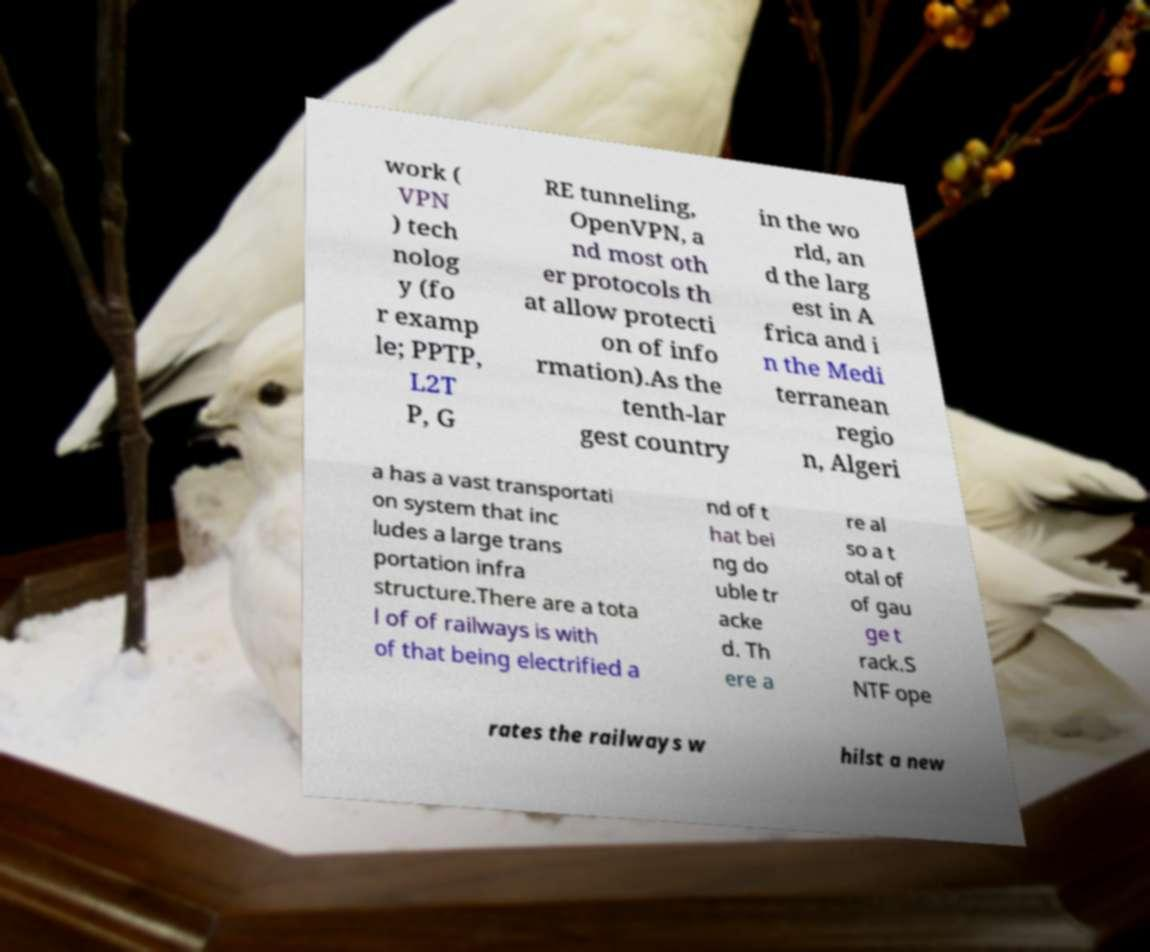Please read and relay the text visible in this image. What does it say? work ( VPN ) tech nolog y (fo r examp le; PPTP, L2T P, G RE tunneling, OpenVPN, a nd most oth er protocols th at allow protecti on of info rmation).As the tenth-lar gest country in the wo rld, an d the larg est in A frica and i n the Medi terranean regio n, Algeri a has a vast transportati on system that inc ludes a large trans portation infra structure.There are a tota l of of railways is with of that being electrified a nd of t hat bei ng do uble tr acke d. Th ere a re al so a t otal of of gau ge t rack.S NTF ope rates the railways w hilst a new 